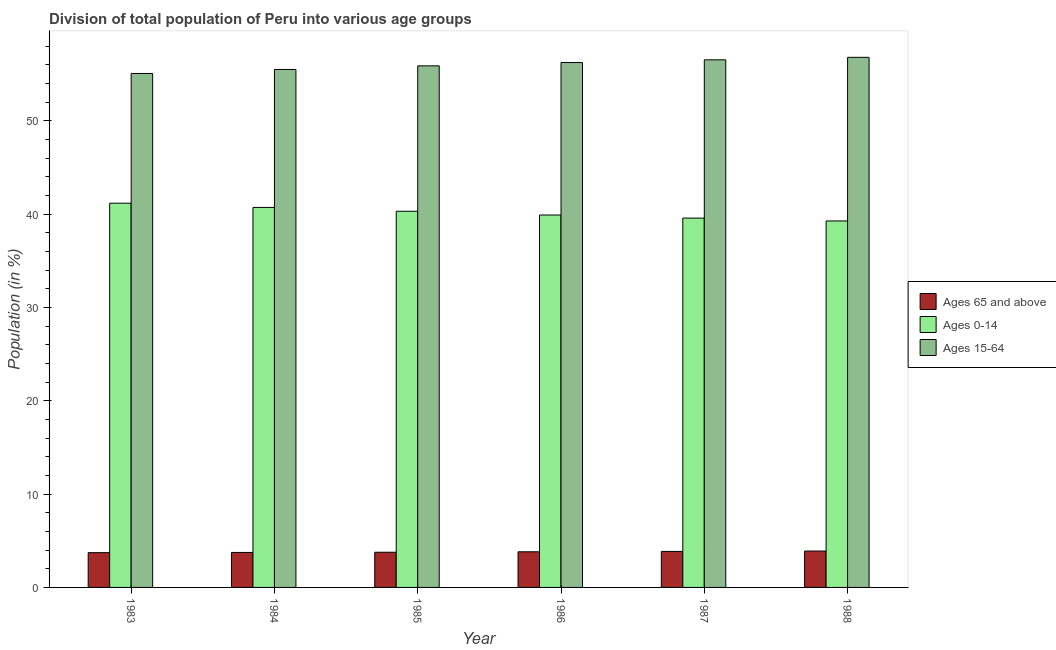How many bars are there on the 3rd tick from the left?
Your answer should be compact. 3. What is the percentage of population within the age-group of 65 and above in 1983?
Your answer should be very brief. 3.73. Across all years, what is the maximum percentage of population within the age-group 15-64?
Your response must be concise. 56.82. Across all years, what is the minimum percentage of population within the age-group 15-64?
Give a very brief answer. 55.09. In which year was the percentage of population within the age-group 15-64 maximum?
Offer a very short reply. 1988. In which year was the percentage of population within the age-group of 65 and above minimum?
Provide a short and direct response. 1983. What is the total percentage of population within the age-group 0-14 in the graph?
Keep it short and to the point. 241.02. What is the difference between the percentage of population within the age-group 15-64 in 1985 and that in 1986?
Offer a terse response. -0.36. What is the difference between the percentage of population within the age-group 0-14 in 1983 and the percentage of population within the age-group of 65 and above in 1984?
Offer a terse response. 0.45. What is the average percentage of population within the age-group 0-14 per year?
Provide a short and direct response. 40.17. In the year 1986, what is the difference between the percentage of population within the age-group 15-64 and percentage of population within the age-group of 65 and above?
Your answer should be very brief. 0. What is the ratio of the percentage of population within the age-group of 65 and above in 1985 to that in 1987?
Offer a terse response. 0.98. Is the percentage of population within the age-group of 65 and above in 1984 less than that in 1988?
Offer a very short reply. Yes. What is the difference between the highest and the second highest percentage of population within the age-group 0-14?
Ensure brevity in your answer.  0.45. What is the difference between the highest and the lowest percentage of population within the age-group of 65 and above?
Offer a very short reply. 0.17. In how many years, is the percentage of population within the age-group of 65 and above greater than the average percentage of population within the age-group of 65 and above taken over all years?
Provide a succinct answer. 3. What does the 1st bar from the left in 1984 represents?
Provide a succinct answer. Ages 65 and above. What does the 3rd bar from the right in 1986 represents?
Make the answer very short. Ages 65 and above. Is it the case that in every year, the sum of the percentage of population within the age-group of 65 and above and percentage of population within the age-group 0-14 is greater than the percentage of population within the age-group 15-64?
Offer a terse response. No. Are all the bars in the graph horizontal?
Provide a succinct answer. No. Where does the legend appear in the graph?
Your answer should be very brief. Center right. How many legend labels are there?
Offer a terse response. 3. How are the legend labels stacked?
Offer a terse response. Vertical. What is the title of the graph?
Provide a short and direct response. Division of total population of Peru into various age groups
. What is the Population (in %) in Ages 65 and above in 1983?
Offer a terse response. 3.73. What is the Population (in %) of Ages 0-14 in 1983?
Make the answer very short. 41.18. What is the Population (in %) in Ages 15-64 in 1983?
Offer a very short reply. 55.09. What is the Population (in %) in Ages 65 and above in 1984?
Your answer should be compact. 3.75. What is the Population (in %) in Ages 0-14 in 1984?
Provide a succinct answer. 40.73. What is the Population (in %) in Ages 15-64 in 1984?
Ensure brevity in your answer.  55.52. What is the Population (in %) of Ages 65 and above in 1985?
Make the answer very short. 3.77. What is the Population (in %) in Ages 0-14 in 1985?
Offer a terse response. 40.32. What is the Population (in %) in Ages 15-64 in 1985?
Give a very brief answer. 55.91. What is the Population (in %) in Ages 65 and above in 1986?
Give a very brief answer. 3.82. What is the Population (in %) of Ages 0-14 in 1986?
Offer a terse response. 39.92. What is the Population (in %) of Ages 15-64 in 1986?
Make the answer very short. 56.26. What is the Population (in %) in Ages 65 and above in 1987?
Offer a terse response. 3.86. What is the Population (in %) of Ages 0-14 in 1987?
Give a very brief answer. 39.59. What is the Population (in %) in Ages 15-64 in 1987?
Your response must be concise. 56.55. What is the Population (in %) in Ages 65 and above in 1988?
Your answer should be very brief. 3.9. What is the Population (in %) in Ages 0-14 in 1988?
Provide a short and direct response. 39.28. What is the Population (in %) in Ages 15-64 in 1988?
Give a very brief answer. 56.82. Across all years, what is the maximum Population (in %) in Ages 65 and above?
Ensure brevity in your answer.  3.9. Across all years, what is the maximum Population (in %) in Ages 0-14?
Give a very brief answer. 41.18. Across all years, what is the maximum Population (in %) in Ages 15-64?
Your answer should be very brief. 56.82. Across all years, what is the minimum Population (in %) of Ages 65 and above?
Provide a succinct answer. 3.73. Across all years, what is the minimum Population (in %) of Ages 0-14?
Keep it short and to the point. 39.28. Across all years, what is the minimum Population (in %) in Ages 15-64?
Your answer should be compact. 55.09. What is the total Population (in %) of Ages 65 and above in the graph?
Make the answer very short. 22.83. What is the total Population (in %) in Ages 0-14 in the graph?
Offer a terse response. 241.02. What is the total Population (in %) of Ages 15-64 in the graph?
Your answer should be very brief. 336.15. What is the difference between the Population (in %) of Ages 65 and above in 1983 and that in 1984?
Offer a very short reply. -0.02. What is the difference between the Population (in %) of Ages 0-14 in 1983 and that in 1984?
Provide a succinct answer. 0.45. What is the difference between the Population (in %) of Ages 15-64 in 1983 and that in 1984?
Your answer should be compact. -0.43. What is the difference between the Population (in %) in Ages 65 and above in 1983 and that in 1985?
Provide a short and direct response. -0.05. What is the difference between the Population (in %) of Ages 0-14 in 1983 and that in 1985?
Give a very brief answer. 0.86. What is the difference between the Population (in %) in Ages 15-64 in 1983 and that in 1985?
Ensure brevity in your answer.  -0.82. What is the difference between the Population (in %) in Ages 65 and above in 1983 and that in 1986?
Make the answer very short. -0.09. What is the difference between the Population (in %) of Ages 0-14 in 1983 and that in 1986?
Ensure brevity in your answer.  1.27. What is the difference between the Population (in %) in Ages 15-64 in 1983 and that in 1986?
Make the answer very short. -1.17. What is the difference between the Population (in %) in Ages 65 and above in 1983 and that in 1987?
Your answer should be very brief. -0.13. What is the difference between the Population (in %) of Ages 0-14 in 1983 and that in 1987?
Keep it short and to the point. 1.6. What is the difference between the Population (in %) of Ages 15-64 in 1983 and that in 1987?
Provide a short and direct response. -1.46. What is the difference between the Population (in %) of Ages 65 and above in 1983 and that in 1988?
Ensure brevity in your answer.  -0.17. What is the difference between the Population (in %) in Ages 0-14 in 1983 and that in 1988?
Ensure brevity in your answer.  1.9. What is the difference between the Population (in %) of Ages 15-64 in 1983 and that in 1988?
Your answer should be compact. -1.73. What is the difference between the Population (in %) in Ages 65 and above in 1984 and that in 1985?
Offer a very short reply. -0.02. What is the difference between the Population (in %) of Ages 0-14 in 1984 and that in 1985?
Offer a terse response. 0.41. What is the difference between the Population (in %) in Ages 15-64 in 1984 and that in 1985?
Make the answer very short. -0.39. What is the difference between the Population (in %) in Ages 65 and above in 1984 and that in 1986?
Your answer should be compact. -0.07. What is the difference between the Population (in %) in Ages 0-14 in 1984 and that in 1986?
Make the answer very short. 0.81. What is the difference between the Population (in %) in Ages 15-64 in 1984 and that in 1986?
Your response must be concise. -0.74. What is the difference between the Population (in %) in Ages 65 and above in 1984 and that in 1987?
Give a very brief answer. -0.11. What is the difference between the Population (in %) of Ages 0-14 in 1984 and that in 1987?
Provide a succinct answer. 1.15. What is the difference between the Population (in %) of Ages 15-64 in 1984 and that in 1987?
Offer a terse response. -1.03. What is the difference between the Population (in %) in Ages 65 and above in 1984 and that in 1988?
Your answer should be very brief. -0.15. What is the difference between the Population (in %) in Ages 0-14 in 1984 and that in 1988?
Offer a terse response. 1.45. What is the difference between the Population (in %) in Ages 15-64 in 1984 and that in 1988?
Provide a short and direct response. -1.3. What is the difference between the Population (in %) in Ages 65 and above in 1985 and that in 1986?
Your answer should be compact. -0.05. What is the difference between the Population (in %) of Ages 0-14 in 1985 and that in 1986?
Provide a short and direct response. 0.4. What is the difference between the Population (in %) of Ages 15-64 in 1985 and that in 1986?
Ensure brevity in your answer.  -0.36. What is the difference between the Population (in %) in Ages 65 and above in 1985 and that in 1987?
Offer a very short reply. -0.09. What is the difference between the Population (in %) in Ages 0-14 in 1985 and that in 1987?
Your answer should be compact. 0.73. What is the difference between the Population (in %) of Ages 15-64 in 1985 and that in 1987?
Your answer should be very brief. -0.65. What is the difference between the Population (in %) of Ages 65 and above in 1985 and that in 1988?
Keep it short and to the point. -0.13. What is the difference between the Population (in %) of Ages 0-14 in 1985 and that in 1988?
Provide a succinct answer. 1.04. What is the difference between the Population (in %) in Ages 15-64 in 1985 and that in 1988?
Offer a terse response. -0.91. What is the difference between the Population (in %) of Ages 65 and above in 1986 and that in 1987?
Make the answer very short. -0.04. What is the difference between the Population (in %) in Ages 0-14 in 1986 and that in 1987?
Your response must be concise. 0.33. What is the difference between the Population (in %) in Ages 15-64 in 1986 and that in 1987?
Your answer should be very brief. -0.29. What is the difference between the Population (in %) in Ages 65 and above in 1986 and that in 1988?
Your response must be concise. -0.08. What is the difference between the Population (in %) of Ages 0-14 in 1986 and that in 1988?
Your answer should be very brief. 0.64. What is the difference between the Population (in %) of Ages 15-64 in 1986 and that in 1988?
Provide a short and direct response. -0.56. What is the difference between the Population (in %) in Ages 65 and above in 1987 and that in 1988?
Give a very brief answer. -0.04. What is the difference between the Population (in %) of Ages 0-14 in 1987 and that in 1988?
Offer a very short reply. 0.31. What is the difference between the Population (in %) of Ages 15-64 in 1987 and that in 1988?
Your answer should be very brief. -0.27. What is the difference between the Population (in %) in Ages 65 and above in 1983 and the Population (in %) in Ages 0-14 in 1984?
Your answer should be compact. -37.01. What is the difference between the Population (in %) of Ages 65 and above in 1983 and the Population (in %) of Ages 15-64 in 1984?
Offer a very short reply. -51.79. What is the difference between the Population (in %) in Ages 0-14 in 1983 and the Population (in %) in Ages 15-64 in 1984?
Your answer should be very brief. -14.33. What is the difference between the Population (in %) in Ages 65 and above in 1983 and the Population (in %) in Ages 0-14 in 1985?
Ensure brevity in your answer.  -36.59. What is the difference between the Population (in %) of Ages 65 and above in 1983 and the Population (in %) of Ages 15-64 in 1985?
Make the answer very short. -52.18. What is the difference between the Population (in %) in Ages 0-14 in 1983 and the Population (in %) in Ages 15-64 in 1985?
Offer a very short reply. -14.72. What is the difference between the Population (in %) in Ages 65 and above in 1983 and the Population (in %) in Ages 0-14 in 1986?
Provide a succinct answer. -36.19. What is the difference between the Population (in %) in Ages 65 and above in 1983 and the Population (in %) in Ages 15-64 in 1986?
Give a very brief answer. -52.54. What is the difference between the Population (in %) of Ages 0-14 in 1983 and the Population (in %) of Ages 15-64 in 1986?
Your response must be concise. -15.08. What is the difference between the Population (in %) of Ages 65 and above in 1983 and the Population (in %) of Ages 0-14 in 1987?
Make the answer very short. -35.86. What is the difference between the Population (in %) in Ages 65 and above in 1983 and the Population (in %) in Ages 15-64 in 1987?
Offer a very short reply. -52.83. What is the difference between the Population (in %) of Ages 0-14 in 1983 and the Population (in %) of Ages 15-64 in 1987?
Your answer should be very brief. -15.37. What is the difference between the Population (in %) in Ages 65 and above in 1983 and the Population (in %) in Ages 0-14 in 1988?
Offer a terse response. -35.56. What is the difference between the Population (in %) in Ages 65 and above in 1983 and the Population (in %) in Ages 15-64 in 1988?
Make the answer very short. -53.09. What is the difference between the Population (in %) of Ages 0-14 in 1983 and the Population (in %) of Ages 15-64 in 1988?
Your response must be concise. -15.64. What is the difference between the Population (in %) in Ages 65 and above in 1984 and the Population (in %) in Ages 0-14 in 1985?
Your answer should be very brief. -36.57. What is the difference between the Population (in %) in Ages 65 and above in 1984 and the Population (in %) in Ages 15-64 in 1985?
Your response must be concise. -52.16. What is the difference between the Population (in %) of Ages 0-14 in 1984 and the Population (in %) of Ages 15-64 in 1985?
Offer a terse response. -15.18. What is the difference between the Population (in %) of Ages 65 and above in 1984 and the Population (in %) of Ages 0-14 in 1986?
Ensure brevity in your answer.  -36.17. What is the difference between the Population (in %) of Ages 65 and above in 1984 and the Population (in %) of Ages 15-64 in 1986?
Your answer should be compact. -52.51. What is the difference between the Population (in %) of Ages 0-14 in 1984 and the Population (in %) of Ages 15-64 in 1986?
Give a very brief answer. -15.53. What is the difference between the Population (in %) in Ages 65 and above in 1984 and the Population (in %) in Ages 0-14 in 1987?
Your answer should be very brief. -35.84. What is the difference between the Population (in %) in Ages 65 and above in 1984 and the Population (in %) in Ages 15-64 in 1987?
Provide a succinct answer. -52.8. What is the difference between the Population (in %) in Ages 0-14 in 1984 and the Population (in %) in Ages 15-64 in 1987?
Provide a short and direct response. -15.82. What is the difference between the Population (in %) in Ages 65 and above in 1984 and the Population (in %) in Ages 0-14 in 1988?
Give a very brief answer. -35.53. What is the difference between the Population (in %) of Ages 65 and above in 1984 and the Population (in %) of Ages 15-64 in 1988?
Your answer should be compact. -53.07. What is the difference between the Population (in %) of Ages 0-14 in 1984 and the Population (in %) of Ages 15-64 in 1988?
Your response must be concise. -16.09. What is the difference between the Population (in %) of Ages 65 and above in 1985 and the Population (in %) of Ages 0-14 in 1986?
Ensure brevity in your answer.  -36.15. What is the difference between the Population (in %) in Ages 65 and above in 1985 and the Population (in %) in Ages 15-64 in 1986?
Provide a succinct answer. -52.49. What is the difference between the Population (in %) of Ages 0-14 in 1985 and the Population (in %) of Ages 15-64 in 1986?
Make the answer very short. -15.94. What is the difference between the Population (in %) of Ages 65 and above in 1985 and the Population (in %) of Ages 0-14 in 1987?
Provide a succinct answer. -35.82. What is the difference between the Population (in %) of Ages 65 and above in 1985 and the Population (in %) of Ages 15-64 in 1987?
Give a very brief answer. -52.78. What is the difference between the Population (in %) of Ages 0-14 in 1985 and the Population (in %) of Ages 15-64 in 1987?
Give a very brief answer. -16.23. What is the difference between the Population (in %) of Ages 65 and above in 1985 and the Population (in %) of Ages 0-14 in 1988?
Make the answer very short. -35.51. What is the difference between the Population (in %) in Ages 65 and above in 1985 and the Population (in %) in Ages 15-64 in 1988?
Make the answer very short. -53.05. What is the difference between the Population (in %) in Ages 0-14 in 1985 and the Population (in %) in Ages 15-64 in 1988?
Offer a terse response. -16.5. What is the difference between the Population (in %) of Ages 65 and above in 1986 and the Population (in %) of Ages 0-14 in 1987?
Your answer should be compact. -35.77. What is the difference between the Population (in %) of Ages 65 and above in 1986 and the Population (in %) of Ages 15-64 in 1987?
Your response must be concise. -52.73. What is the difference between the Population (in %) in Ages 0-14 in 1986 and the Population (in %) in Ages 15-64 in 1987?
Offer a terse response. -16.63. What is the difference between the Population (in %) of Ages 65 and above in 1986 and the Population (in %) of Ages 0-14 in 1988?
Your answer should be compact. -35.46. What is the difference between the Population (in %) of Ages 65 and above in 1986 and the Population (in %) of Ages 15-64 in 1988?
Offer a very short reply. -53. What is the difference between the Population (in %) of Ages 0-14 in 1986 and the Population (in %) of Ages 15-64 in 1988?
Ensure brevity in your answer.  -16.9. What is the difference between the Population (in %) of Ages 65 and above in 1987 and the Population (in %) of Ages 0-14 in 1988?
Make the answer very short. -35.42. What is the difference between the Population (in %) of Ages 65 and above in 1987 and the Population (in %) of Ages 15-64 in 1988?
Your response must be concise. -52.96. What is the difference between the Population (in %) of Ages 0-14 in 1987 and the Population (in %) of Ages 15-64 in 1988?
Ensure brevity in your answer.  -17.23. What is the average Population (in %) of Ages 65 and above per year?
Your response must be concise. 3.8. What is the average Population (in %) of Ages 0-14 per year?
Keep it short and to the point. 40.17. What is the average Population (in %) of Ages 15-64 per year?
Give a very brief answer. 56.02. In the year 1983, what is the difference between the Population (in %) in Ages 65 and above and Population (in %) in Ages 0-14?
Make the answer very short. -37.46. In the year 1983, what is the difference between the Population (in %) of Ages 65 and above and Population (in %) of Ages 15-64?
Ensure brevity in your answer.  -51.36. In the year 1983, what is the difference between the Population (in %) of Ages 0-14 and Population (in %) of Ages 15-64?
Your response must be concise. -13.9. In the year 1984, what is the difference between the Population (in %) of Ages 65 and above and Population (in %) of Ages 0-14?
Keep it short and to the point. -36.98. In the year 1984, what is the difference between the Population (in %) in Ages 65 and above and Population (in %) in Ages 15-64?
Your response must be concise. -51.77. In the year 1984, what is the difference between the Population (in %) of Ages 0-14 and Population (in %) of Ages 15-64?
Provide a succinct answer. -14.79. In the year 1985, what is the difference between the Population (in %) of Ages 65 and above and Population (in %) of Ages 0-14?
Your answer should be very brief. -36.55. In the year 1985, what is the difference between the Population (in %) in Ages 65 and above and Population (in %) in Ages 15-64?
Offer a terse response. -52.14. In the year 1985, what is the difference between the Population (in %) in Ages 0-14 and Population (in %) in Ages 15-64?
Your answer should be compact. -15.59. In the year 1986, what is the difference between the Population (in %) of Ages 65 and above and Population (in %) of Ages 0-14?
Offer a terse response. -36.1. In the year 1986, what is the difference between the Population (in %) of Ages 65 and above and Population (in %) of Ages 15-64?
Your response must be concise. -52.44. In the year 1986, what is the difference between the Population (in %) of Ages 0-14 and Population (in %) of Ages 15-64?
Offer a terse response. -16.34. In the year 1987, what is the difference between the Population (in %) of Ages 65 and above and Population (in %) of Ages 0-14?
Make the answer very short. -35.73. In the year 1987, what is the difference between the Population (in %) of Ages 65 and above and Population (in %) of Ages 15-64?
Give a very brief answer. -52.69. In the year 1987, what is the difference between the Population (in %) of Ages 0-14 and Population (in %) of Ages 15-64?
Your answer should be very brief. -16.97. In the year 1988, what is the difference between the Population (in %) in Ages 65 and above and Population (in %) in Ages 0-14?
Offer a very short reply. -35.38. In the year 1988, what is the difference between the Population (in %) in Ages 65 and above and Population (in %) in Ages 15-64?
Give a very brief answer. -52.92. In the year 1988, what is the difference between the Population (in %) of Ages 0-14 and Population (in %) of Ages 15-64?
Make the answer very short. -17.54. What is the ratio of the Population (in %) of Ages 65 and above in 1983 to that in 1984?
Offer a very short reply. 0.99. What is the ratio of the Population (in %) in Ages 0-14 in 1983 to that in 1984?
Keep it short and to the point. 1.01. What is the ratio of the Population (in %) in Ages 0-14 in 1983 to that in 1985?
Your answer should be compact. 1.02. What is the ratio of the Population (in %) of Ages 15-64 in 1983 to that in 1985?
Ensure brevity in your answer.  0.99. What is the ratio of the Population (in %) of Ages 65 and above in 1983 to that in 1986?
Provide a succinct answer. 0.98. What is the ratio of the Population (in %) of Ages 0-14 in 1983 to that in 1986?
Your answer should be compact. 1.03. What is the ratio of the Population (in %) of Ages 15-64 in 1983 to that in 1986?
Ensure brevity in your answer.  0.98. What is the ratio of the Population (in %) of Ages 65 and above in 1983 to that in 1987?
Your response must be concise. 0.97. What is the ratio of the Population (in %) of Ages 0-14 in 1983 to that in 1987?
Give a very brief answer. 1.04. What is the ratio of the Population (in %) of Ages 15-64 in 1983 to that in 1987?
Offer a terse response. 0.97. What is the ratio of the Population (in %) of Ages 65 and above in 1983 to that in 1988?
Your answer should be compact. 0.96. What is the ratio of the Population (in %) of Ages 0-14 in 1983 to that in 1988?
Make the answer very short. 1.05. What is the ratio of the Population (in %) in Ages 15-64 in 1983 to that in 1988?
Your response must be concise. 0.97. What is the ratio of the Population (in %) of Ages 65 and above in 1984 to that in 1985?
Provide a succinct answer. 0.99. What is the ratio of the Population (in %) in Ages 0-14 in 1984 to that in 1985?
Keep it short and to the point. 1.01. What is the ratio of the Population (in %) in Ages 15-64 in 1984 to that in 1985?
Your answer should be compact. 0.99. What is the ratio of the Population (in %) in Ages 65 and above in 1984 to that in 1986?
Your answer should be very brief. 0.98. What is the ratio of the Population (in %) of Ages 0-14 in 1984 to that in 1986?
Your answer should be compact. 1.02. What is the ratio of the Population (in %) of Ages 15-64 in 1984 to that in 1986?
Your response must be concise. 0.99. What is the ratio of the Population (in %) in Ages 65 and above in 1984 to that in 1987?
Your answer should be compact. 0.97. What is the ratio of the Population (in %) of Ages 0-14 in 1984 to that in 1987?
Ensure brevity in your answer.  1.03. What is the ratio of the Population (in %) of Ages 15-64 in 1984 to that in 1987?
Make the answer very short. 0.98. What is the ratio of the Population (in %) of Ages 65 and above in 1984 to that in 1988?
Offer a terse response. 0.96. What is the ratio of the Population (in %) in Ages 0-14 in 1984 to that in 1988?
Keep it short and to the point. 1.04. What is the ratio of the Population (in %) of Ages 15-64 in 1984 to that in 1988?
Make the answer very short. 0.98. What is the ratio of the Population (in %) in Ages 65 and above in 1985 to that in 1986?
Keep it short and to the point. 0.99. What is the ratio of the Population (in %) of Ages 0-14 in 1985 to that in 1986?
Your answer should be compact. 1.01. What is the ratio of the Population (in %) in Ages 65 and above in 1985 to that in 1987?
Offer a terse response. 0.98. What is the ratio of the Population (in %) of Ages 0-14 in 1985 to that in 1987?
Provide a short and direct response. 1.02. What is the ratio of the Population (in %) in Ages 65 and above in 1985 to that in 1988?
Give a very brief answer. 0.97. What is the ratio of the Population (in %) in Ages 0-14 in 1985 to that in 1988?
Your answer should be very brief. 1.03. What is the ratio of the Population (in %) in Ages 15-64 in 1985 to that in 1988?
Offer a terse response. 0.98. What is the ratio of the Population (in %) in Ages 65 and above in 1986 to that in 1987?
Offer a terse response. 0.99. What is the ratio of the Population (in %) in Ages 0-14 in 1986 to that in 1987?
Your response must be concise. 1.01. What is the ratio of the Population (in %) of Ages 15-64 in 1986 to that in 1987?
Your response must be concise. 0.99. What is the ratio of the Population (in %) of Ages 65 and above in 1986 to that in 1988?
Give a very brief answer. 0.98. What is the ratio of the Population (in %) of Ages 0-14 in 1986 to that in 1988?
Keep it short and to the point. 1.02. What is the ratio of the Population (in %) in Ages 15-64 in 1986 to that in 1988?
Keep it short and to the point. 0.99. What is the ratio of the Population (in %) in Ages 65 and above in 1987 to that in 1988?
Provide a succinct answer. 0.99. What is the difference between the highest and the second highest Population (in %) in Ages 65 and above?
Your answer should be compact. 0.04. What is the difference between the highest and the second highest Population (in %) of Ages 0-14?
Provide a succinct answer. 0.45. What is the difference between the highest and the second highest Population (in %) in Ages 15-64?
Provide a short and direct response. 0.27. What is the difference between the highest and the lowest Population (in %) in Ages 65 and above?
Give a very brief answer. 0.17. What is the difference between the highest and the lowest Population (in %) in Ages 0-14?
Give a very brief answer. 1.9. What is the difference between the highest and the lowest Population (in %) of Ages 15-64?
Ensure brevity in your answer.  1.73. 